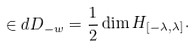<formula> <loc_0><loc_0><loc_500><loc_500>\in d D _ { - w } = \frac { 1 } { 2 } \dim H _ { [ - \lambda , \lambda ] } .</formula> 